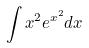Convert formula to latex. <formula><loc_0><loc_0><loc_500><loc_500>\int x ^ { 2 } e ^ { x ^ { 2 } } d x</formula> 